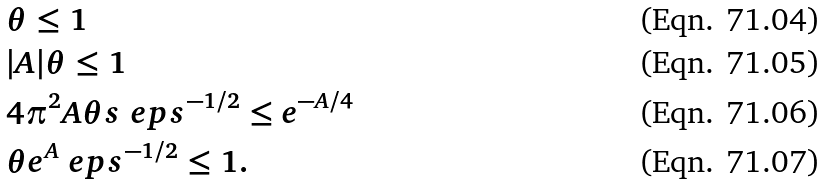<formula> <loc_0><loc_0><loc_500><loc_500>& \theta \leq 1 \\ & | A | \theta \leq 1 \\ & 4 \pi ^ { 2 } A \theta s \ e p s ^ { - 1 / 2 } \leq e ^ { - A / 4 } \\ & \theta e ^ { A } \ e p s ^ { - 1 / 2 } \leq 1 .</formula> 